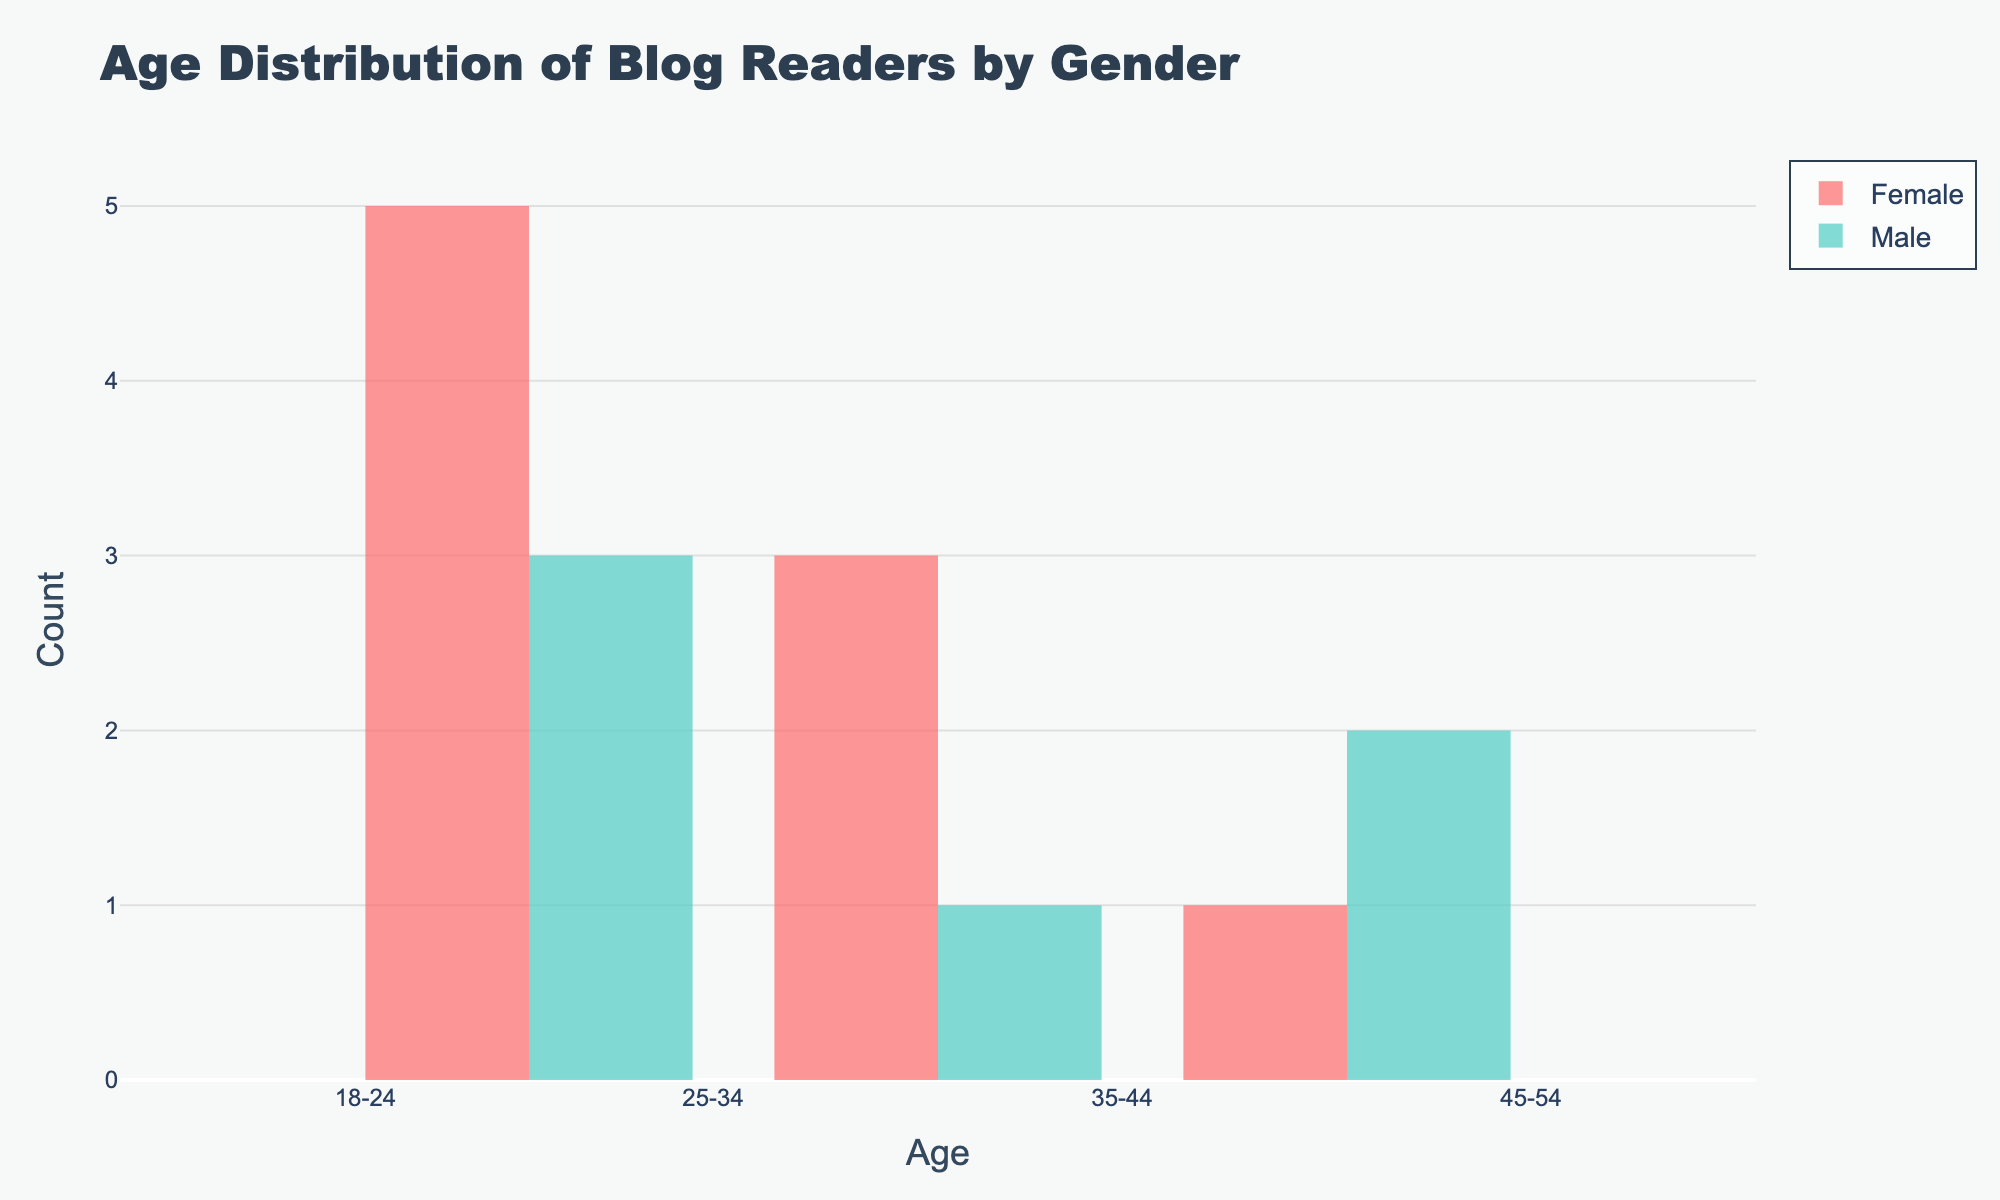What is the title of the plot? The title is usually found at the top of the plot. In this case, the title is "Age Distribution of Blog Readers by Gender".
Answer: Age Distribution of Blog Readers by Gender What is the range of ages displayed on the x-axis? The x-axis range is clearly marked at the bottom of the plot, and it extends from 15 to 55.
Answer: 15-55 How many unique age groups are shown in the plot? On the x-axis, four specific tick values represent distinct age groups: 18-24, 25-34, 35-44, and 45-54.
Answer: 4 Which gender is represented by the color red? In the plot legend, gender representations are shown by color, and red represents the female gender.
Answer: Female Which gender has a higher frequency of blog readers in the 35-44 age group? By observing the height of the bars at the position corresponding to the 35-44 age group, the taller bar represents the female gender.
Answer: Female What is the count of male readers in the 25-34 age range? By referring to the bar height for males (in green) over the 25-34 age range, we can determine the count.
Answer: 2 Comparing 18-24 and 45-54 age groups, which has more female readers? By comparing the heights of red bars for these age groups, the bar for 18-24 is noticeably higher than that for 45-54.
Answer: 18-24 Is there any age group where male blog readers outnumber female blog readers? By checking the heights of bars for both genders across all age groups, there is no age group where male readers surpass female readers.
Answer: No What is the average age of the blog readers who interact with sponsored content? To find the average age, convert age groups to midpoints (21, 29.5, 39.5, and 49.5), then average these values, taking into account the frequency of readers in each group. However, here it’s more intuitive to see that readers are distributed fairly evenly across the age groups.
Answer: 34-35 